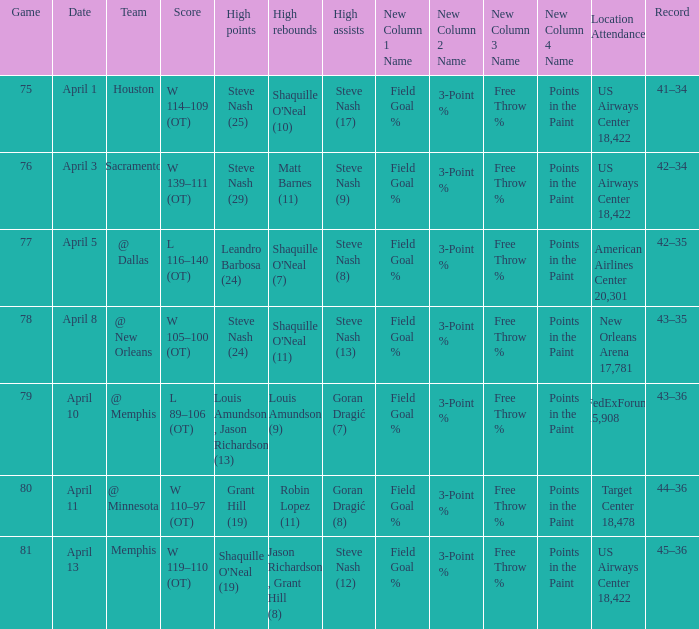What was the team's score on April 1? W 114–109 (OT). 